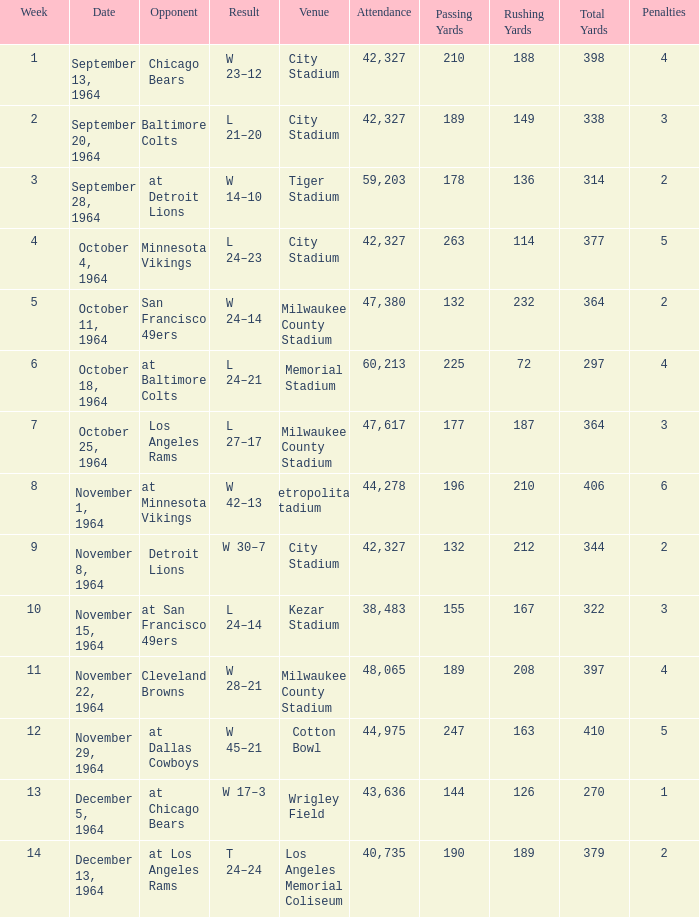At what site did the game that concluded with a 24-14 score take place? Kezar Stadium. 